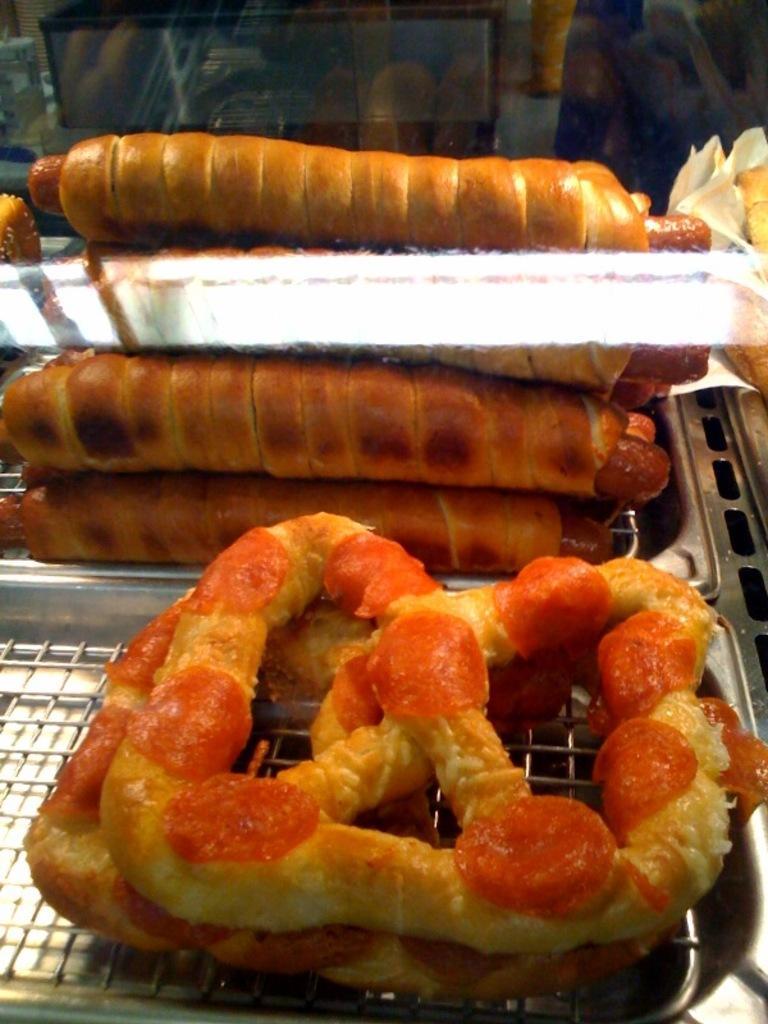Please provide a concise description of this image. In this image there is a food, grill and objects. 